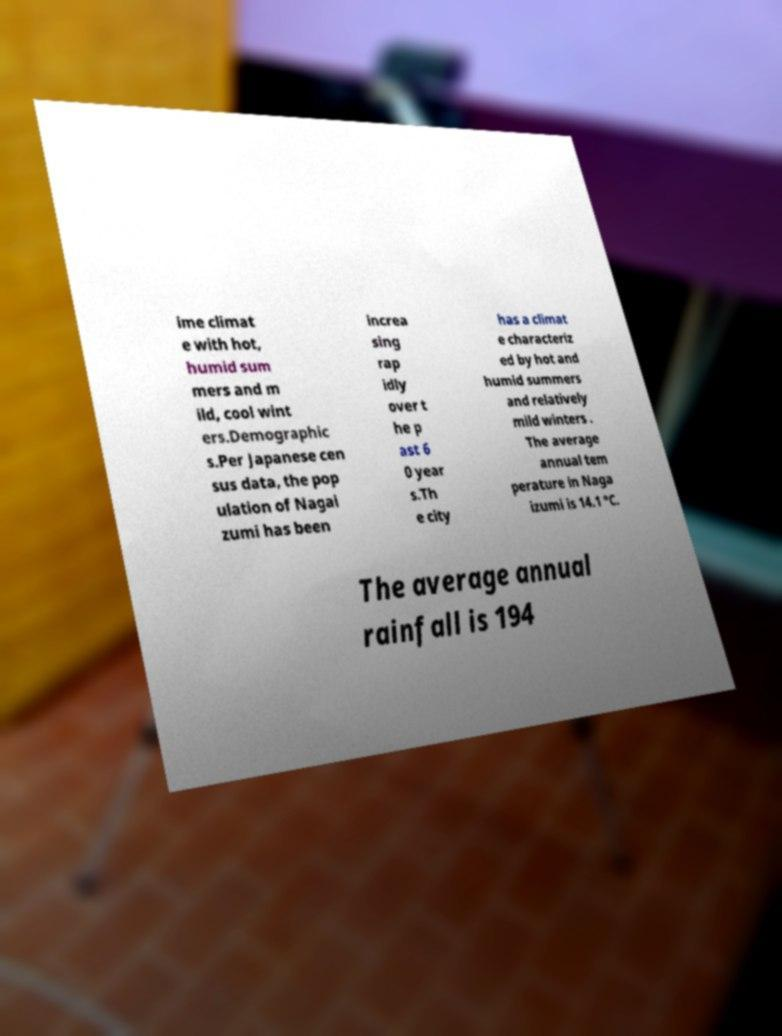For documentation purposes, I need the text within this image transcribed. Could you provide that? ime climat e with hot, humid sum mers and m ild, cool wint ers.Demographic s.Per Japanese cen sus data, the pop ulation of Nagai zumi has been increa sing rap idly over t he p ast 6 0 year s.Th e city has a climat e characteriz ed by hot and humid summers and relatively mild winters . The average annual tem perature in Naga izumi is 14.1 °C. The average annual rainfall is 194 